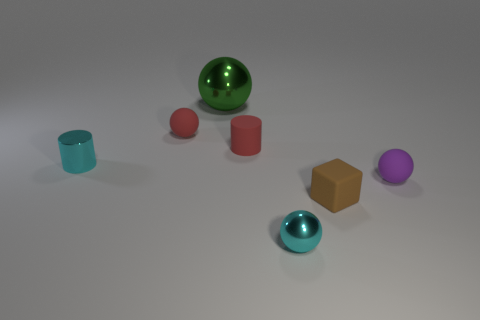Add 1 large spheres. How many objects exist? 8 Subtract all yellow spheres. Subtract all green cubes. How many spheres are left? 4 Subtract all blocks. How many objects are left? 6 Add 2 tiny red cylinders. How many tiny red cylinders exist? 3 Subtract 0 brown spheres. How many objects are left? 7 Subtract all yellow cylinders. Subtract all small purple matte objects. How many objects are left? 6 Add 2 cyan metallic things. How many cyan metallic things are left? 4 